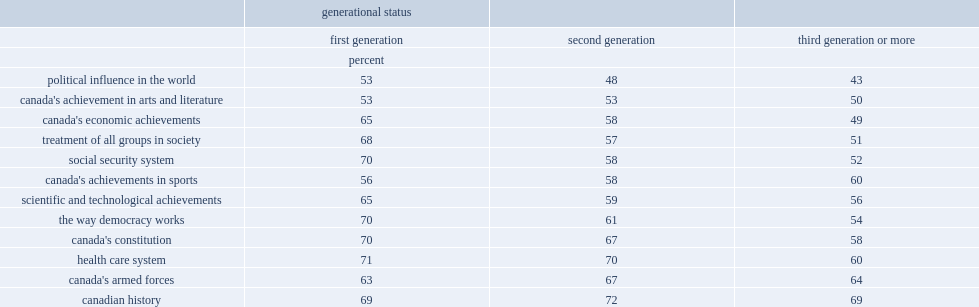On the economic side, what percent of second generation immigrants were either proud or very proud of canada's accomplishments? 58. What percent of other non-immigrants is pround of canada's economic achievements? 49. 